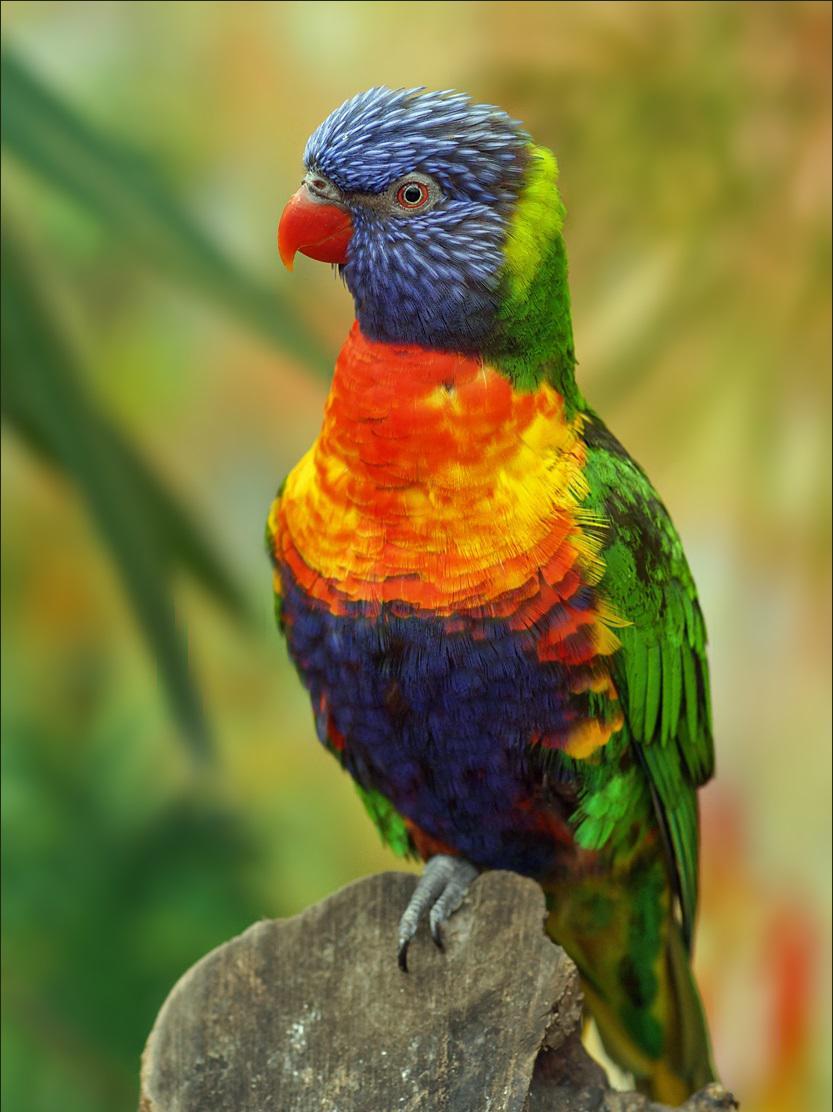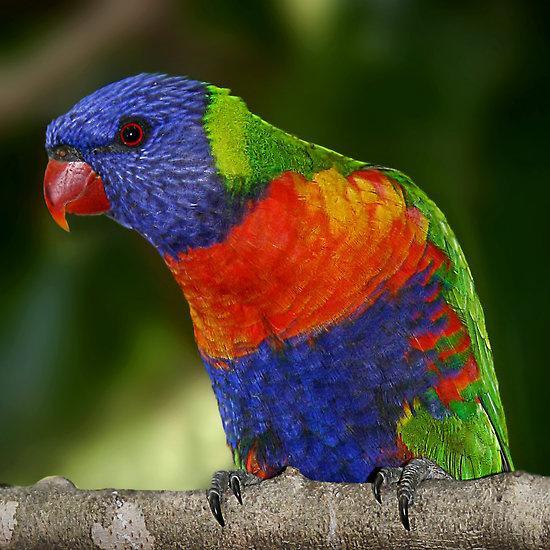The first image is the image on the left, the second image is the image on the right. Considering the images on both sides, is "All of the images contain at least two parrots." valid? Answer yes or no. No. 